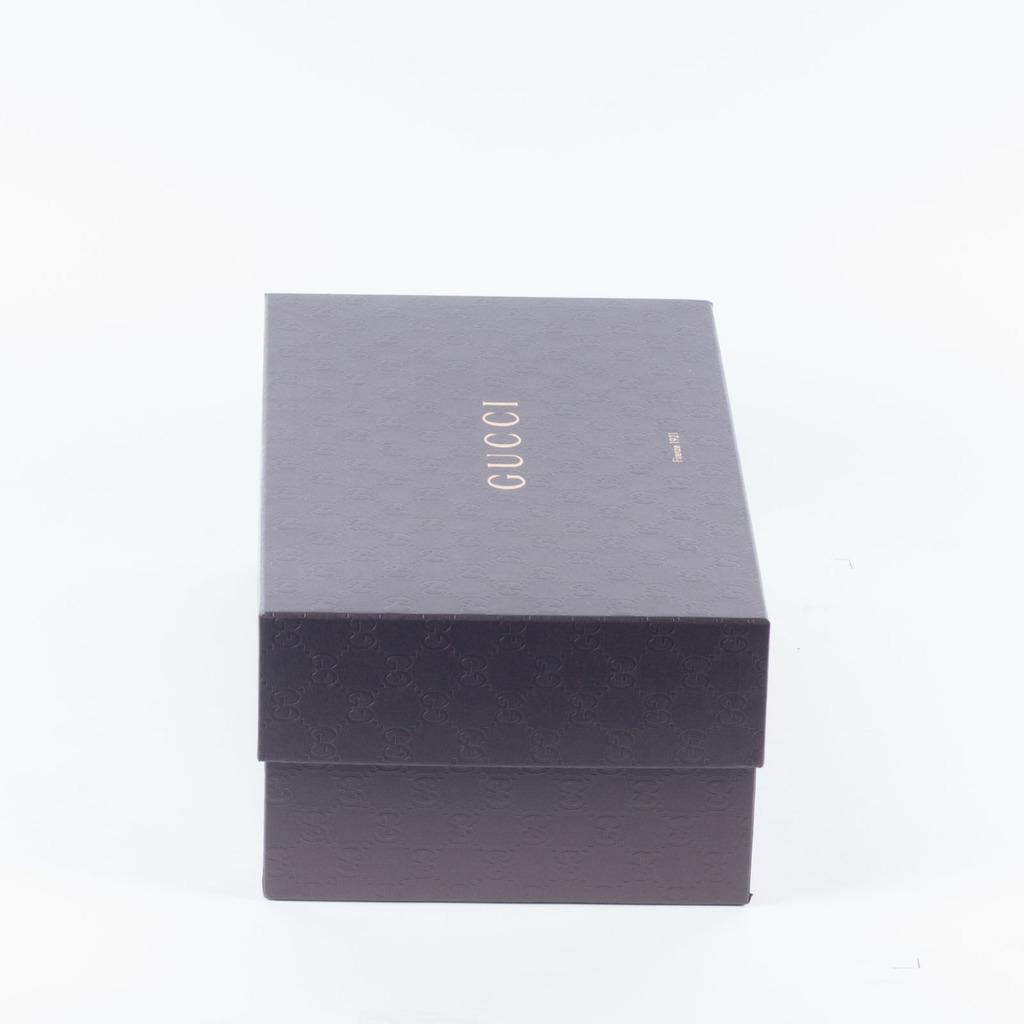<image>
Offer a succinct explanation of the picture presented. A small rectangular Gucci box has the lid on it. 